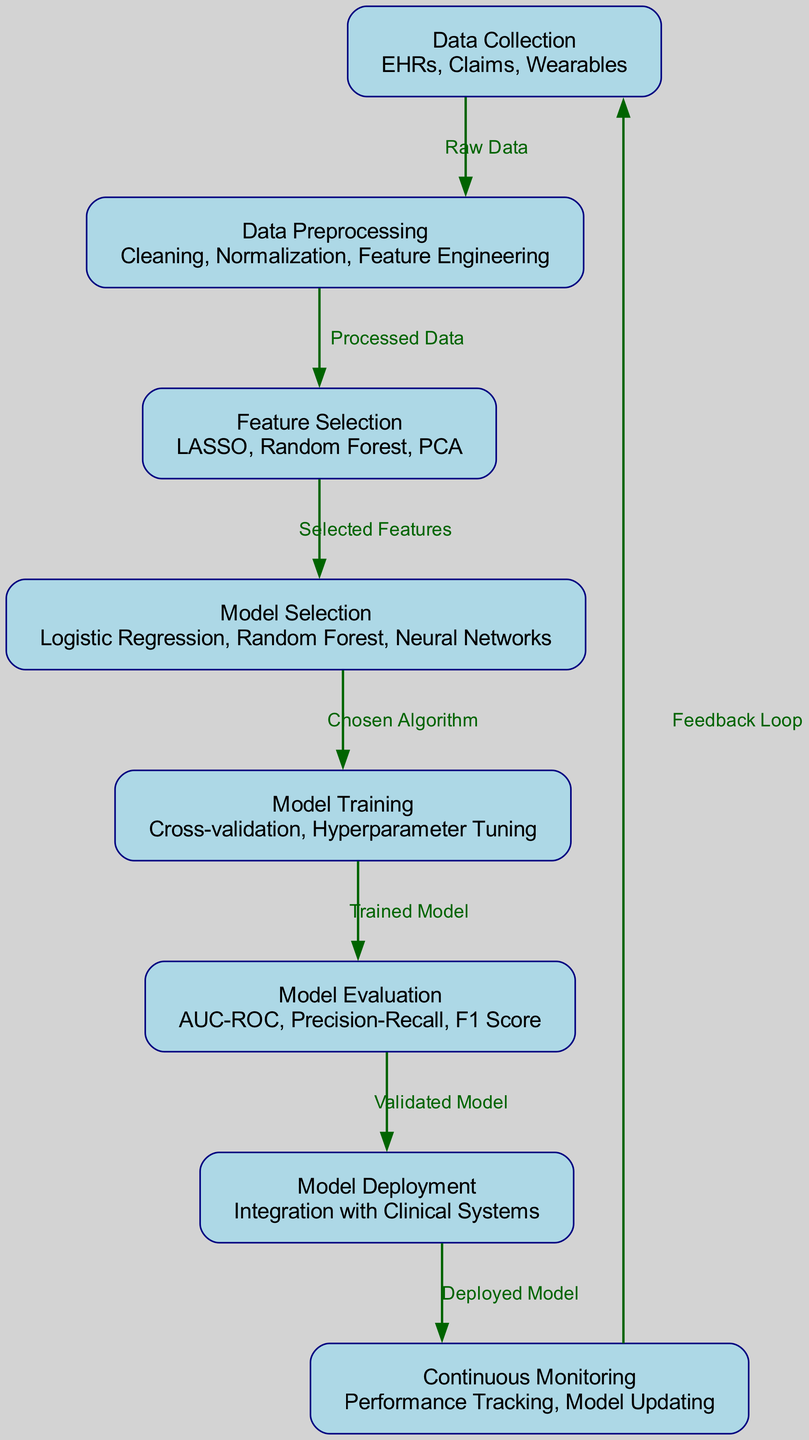What is the first step in the machine learning pipeline? The first node in the diagram is "Data Collection," indicating that this is the starting point of the machine learning pipeline.
Answer: Data Collection How many nodes are in the diagram? By counting the nodes present in the diagram, we find there are eight distinct nodes representing various stages of the machine learning pipeline.
Answer: Eight What connects "Model Evaluation" to "Model Deployment"? The edge from "Model Evaluation" to "Model Deployment" indicates that the output, which is the validated model, serves as the input to the model deployment stage.
Answer: Validated Model Which node follows "Feature Selection"? In the flow of the diagram, the node "Model Selection" immediately follows "Feature Selection," indicating the next step after selecting features.
Answer: Model Selection What is the feedback loop in this pipeline? The edge returning from "Continuous Monitoring" to "Data Collection" signifies that feedback from monitoring is used to refine the data collection process, creating a cyclical improvement in the pipeline.
Answer: Feedback Loop What types of algorithms are listed under "Model Selection"? The node "Model Selection" includes Logistic Regression, Random Forest, and Neural Networks, which are the types of algorithms identified in this stage.
Answer: Logistic Regression, Random Forest, Neural Networks What is the relationship between "Model Training" and "Model Evaluation"? "Model Training" outputs the trained model, which is then evaluated in the "Model Evaluation" stage to assess its performance using various metrics.
Answer: Trained Model Which stage involves performance tracking? The node labeled "Continuous Monitoring" is responsible for performance tracking, indicating ongoing assessment and updates of the deployed model.
Answer: Continuous Monitoring 